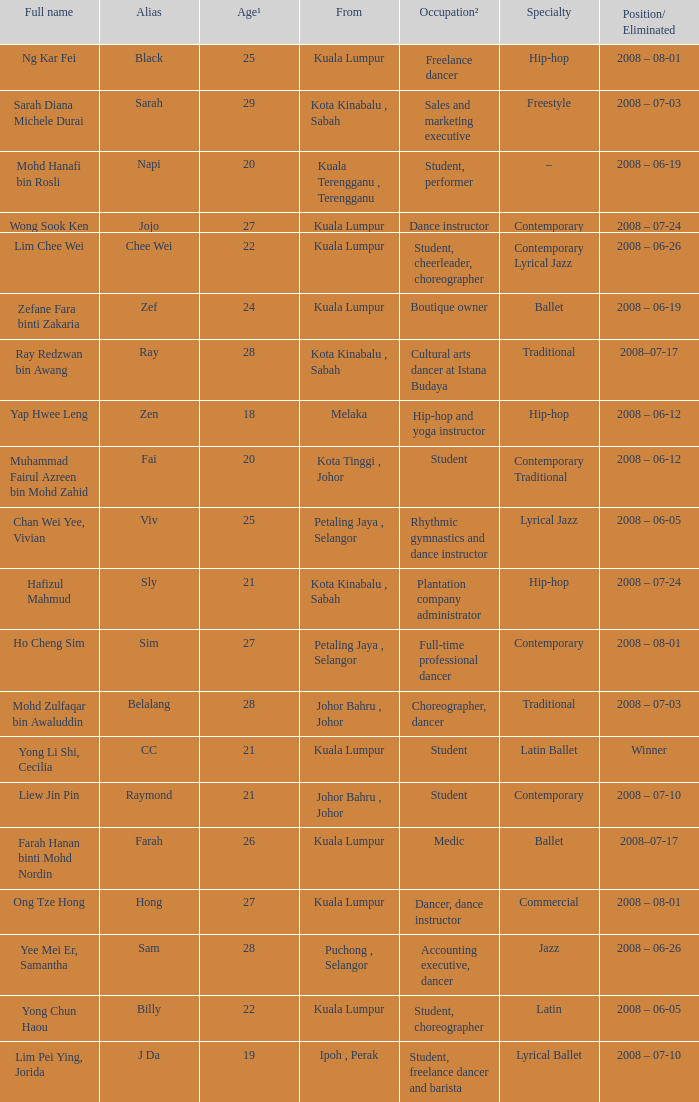What is the occupation² if age¹ is over 24 and alias is identified as "black"? Freelance dancer. 